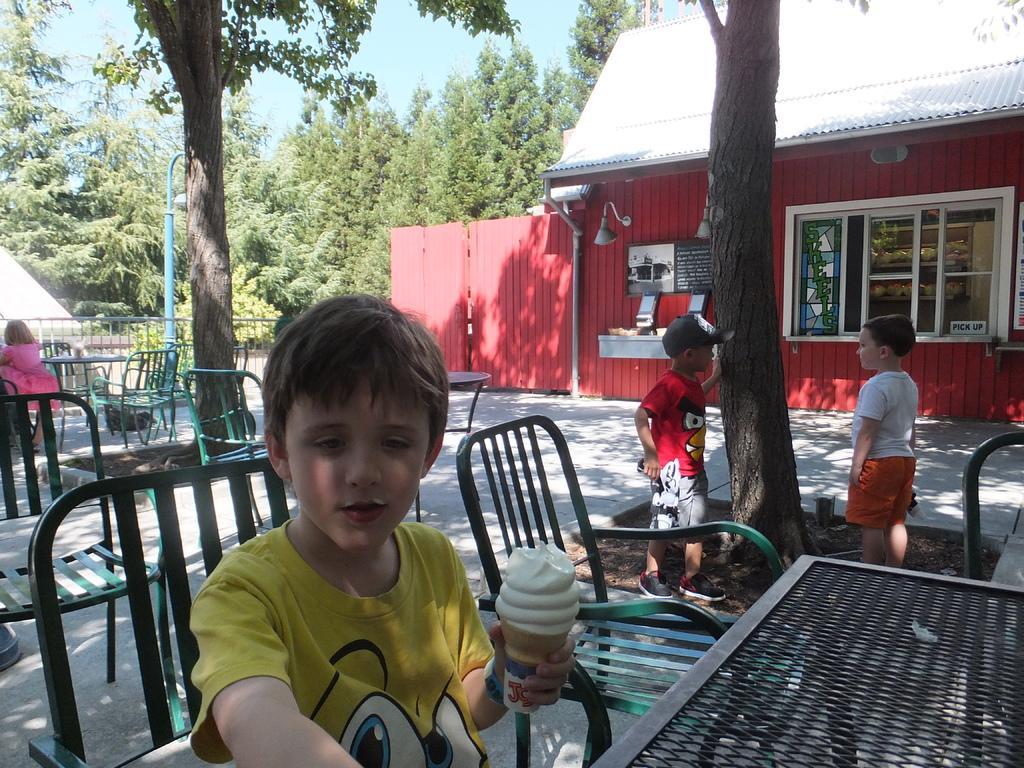Could you give a brief overview of what you see in this image? As we can see in the image, there are trees, house, window, tables and chairs and the boy who is sitting here is holding ice cream. 